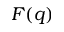Convert formula to latex. <formula><loc_0><loc_0><loc_500><loc_500>F ( q )</formula> 